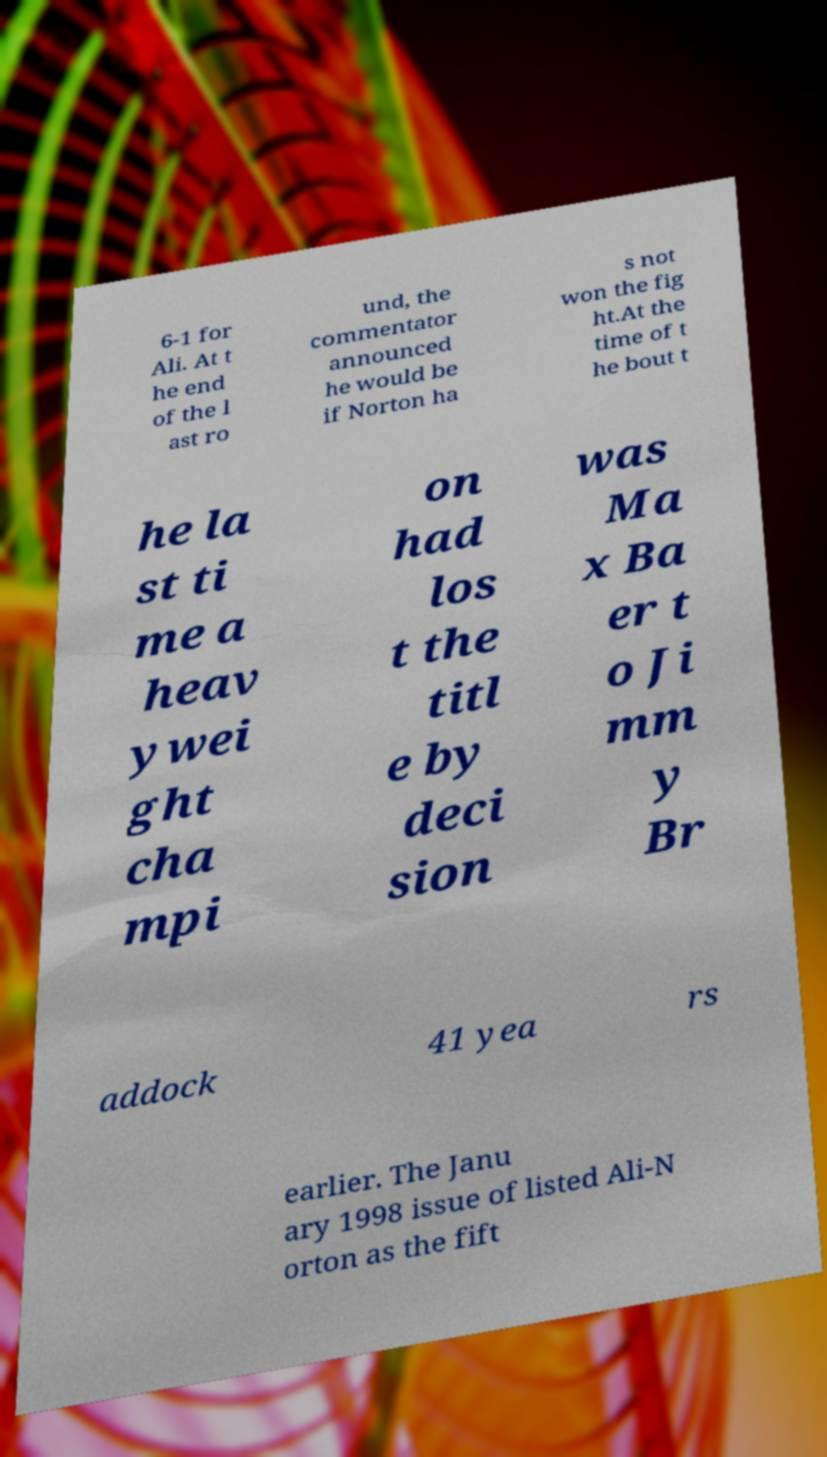Please identify and transcribe the text found in this image. 6-1 for Ali. At t he end of the l ast ro und, the commentator announced he would be if Norton ha s not won the fig ht.At the time of t he bout t he la st ti me a heav ywei ght cha mpi on had los t the titl e by deci sion was Ma x Ba er t o Ji mm y Br addock 41 yea rs earlier. The Janu ary 1998 issue of listed Ali-N orton as the fift 